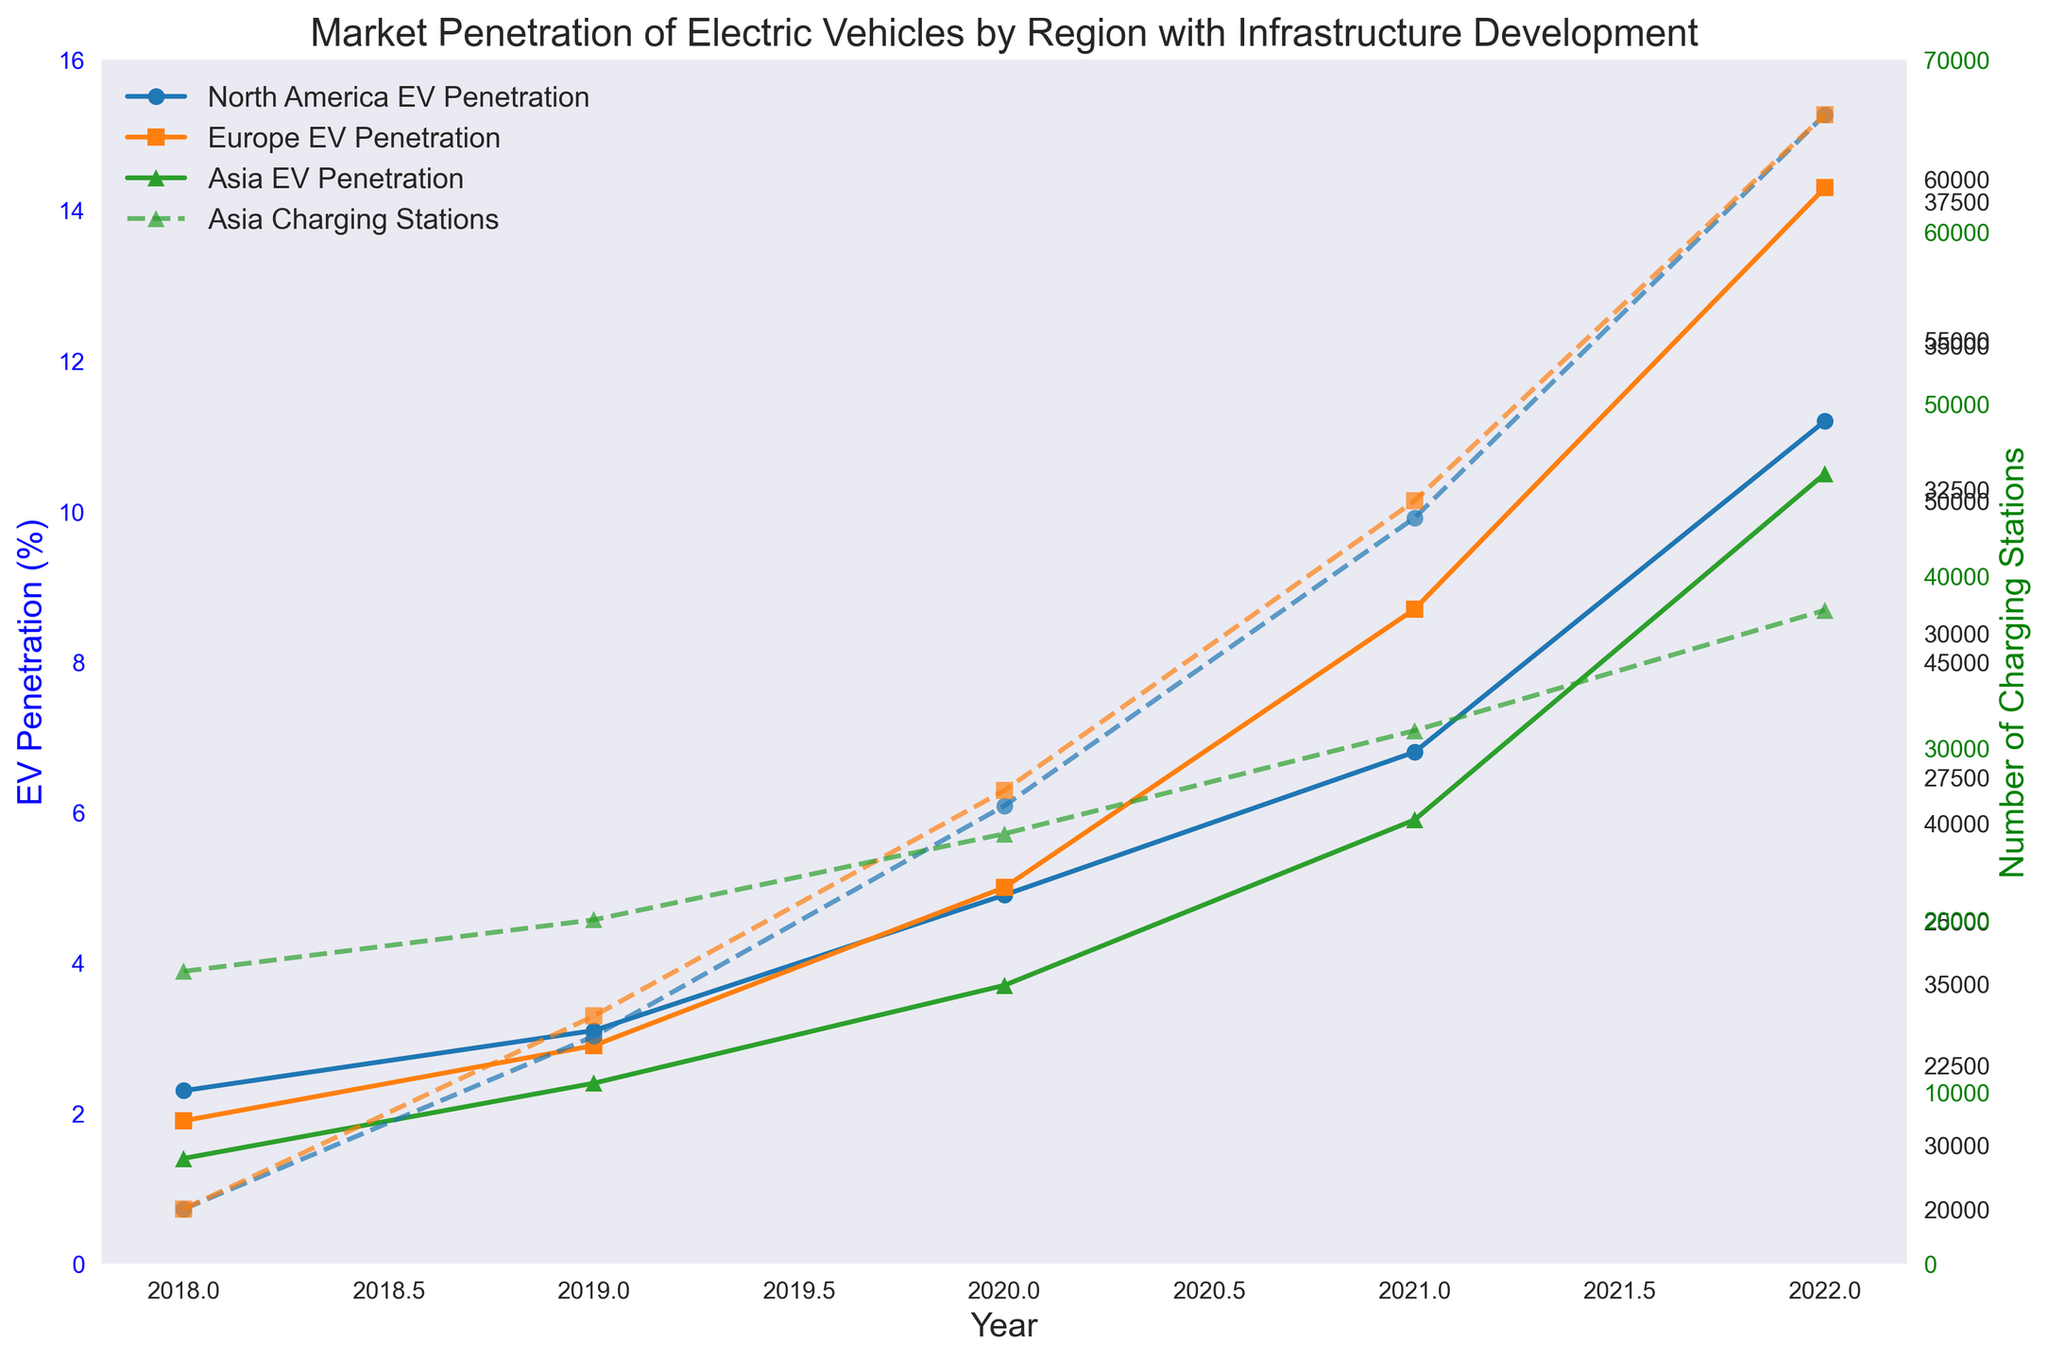What was the EV penetration in North America in 2020? Look at the line representing North America (blue with circles) and locate the value for the year 2020.
Answer: 4.9% Which region had the highest number of charging stations in 2022? Compare the end points of the dashed lines for all three regions in 2022. Europe has the highest endpoint.
Answer: Europe By how much did the number of charging stations in Asia grow from 2019 to 2022? Identify the values for 2019 (20,000) and 2022 (38,000) on the dashed green line for Asia, then calculate the difference: 38,000 - 20,000.
Answer: 18,000 Which region had the greatest increase in EV penetration from 2018 to 2022? Examine the differences in EV penetration values from 2018 to 2022 for all regions: North America (11.2 - 2.3), Europe (14.3 - 1.9), and Asia (10.5 - 1.4). Europe has the largest difference.
Answer: Europe In which year did North America surpass 5% EV penetration? Follow the blue line with circles for North America and identify the first year where the EV penetration exceeds 5%, which is between 2019 (3.1%) and 2020 (4.9%).
Answer: 2021 What was the average annual growth rate of charging stations in Europe from 2018 to 2022? Calculate the total increase in charging stations: 62,000 - 28,000 = 34,000. Then count the number of years: 2022 - 2018 = 4 years, the average annual growth rate is 34,000 / 4.
Answer: 8,500 per year Compare EV penetration between Europe and Asia in 2020. Find the EV penetration for both regions in 2020: Europe is 5.0%, and Asia is 3.7%.
Answer: Europe is higher By what percentage did the number of charging stations in North America grow from 2018 to 2022? Calculate the percentage increase: ((39,000 - 20,000) / 20,000) * 100%.
Answer: 95% What is the ratio of EV penetration in Europe to that in Asia in 2022? Identify the EV penetration in Europe (14.3%) and Asia (10.5%) in 2022. Then, calculate the ratio 14.3 / 10.5.
Answer: Approx. 1.36 Which region shows a faster growth in charging stations after 2020, Asia or Europe? Compare the growth rates from 2020 to 2022. Europe’s growth: 62,000 - 41,000 = 21,000, Asia’s growth: 38,000 - 25,000 = 13,000. Europe has a higher growth.
Answer: Europe 